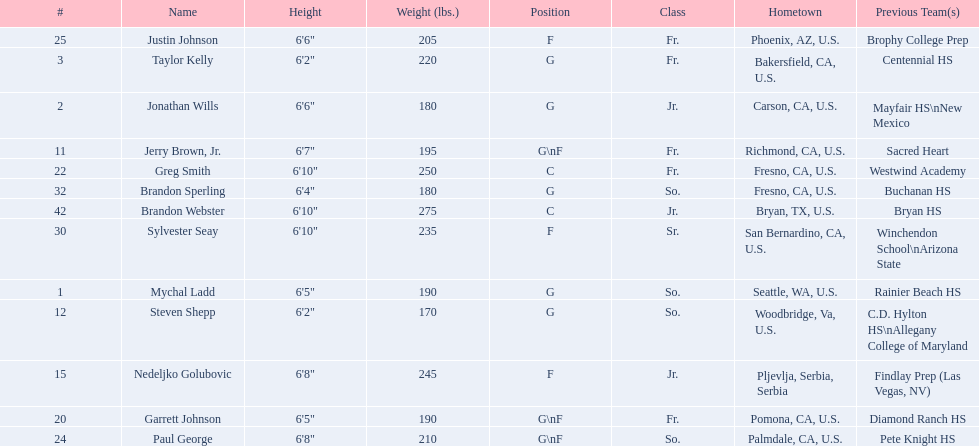Which player is taller, paul george or greg smith? Greg Smith. Write the full table. {'header': ['#', 'Name', 'Height', 'Weight (lbs.)', 'Position', 'Class', 'Hometown', 'Previous Team(s)'], 'rows': [['25', 'Justin Johnson', '6\'6"', '205', 'F', 'Fr.', 'Phoenix, AZ, U.S.', 'Brophy College Prep'], ['3', 'Taylor Kelly', '6\'2"', '220', 'G', 'Fr.', 'Bakersfield, CA, U.S.', 'Centennial HS'], ['2', 'Jonathan Wills', '6\'6"', '180', 'G', 'Jr.', 'Carson, CA, U.S.', 'Mayfair HS\\nNew Mexico'], ['11', 'Jerry Brown, Jr.', '6\'7"', '195', 'G\\nF', 'Fr.', 'Richmond, CA, U.S.', 'Sacred Heart'], ['22', 'Greg Smith', '6\'10"', '250', 'C', 'Fr.', 'Fresno, CA, U.S.', 'Westwind Academy'], ['32', 'Brandon Sperling', '6\'4"', '180', 'G', 'So.', 'Fresno, CA, U.S.', 'Buchanan HS'], ['42', 'Brandon Webster', '6\'10"', '275', 'C', 'Jr.', 'Bryan, TX, U.S.', 'Bryan HS'], ['30', 'Sylvester Seay', '6\'10"', '235', 'F', 'Sr.', 'San Bernardino, CA, U.S.', 'Winchendon School\\nArizona State'], ['1', 'Mychal Ladd', '6\'5"', '190', 'G', 'So.', 'Seattle, WA, U.S.', 'Rainier Beach HS'], ['12', 'Steven Shepp', '6\'2"', '170', 'G', 'So.', 'Woodbridge, Va, U.S.', 'C.D. Hylton HS\\nAllegany College of Maryland'], ['15', 'Nedeljko Golubovic', '6\'8"', '245', 'F', 'Jr.', 'Pljevlja, Serbia, Serbia', 'Findlay Prep (Las Vegas, NV)'], ['20', 'Garrett Johnson', '6\'5"', '190', 'G\\nF', 'Fr.', 'Pomona, CA, U.S.', 'Diamond Ranch HS'], ['24', 'Paul George', '6\'8"', '210', 'G\\nF', 'So.', 'Palmdale, CA, U.S.', 'Pete Knight HS']]} 